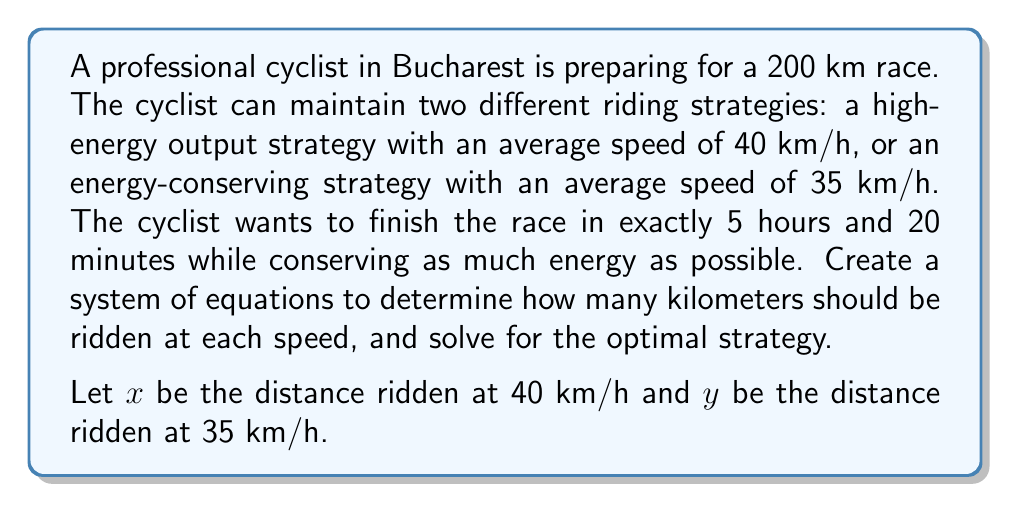Provide a solution to this math problem. To solve this problem, we need to set up a system of two equations based on the given information:

1. The total distance equation:
   $$x + y = 200$$
   This equation represents the fact that the sum of distances ridden at both speeds must equal the total race distance of 200 km.

2. The total time equation:
   $$\frac{x}{40} + \frac{y}{35} = \frac{16}{3}$$
   This equation represents the total time taken, which should be 5 hours and 20 minutes (or 16/3 hours).

Now we have a system of two equations with two unknowns:

$$\begin{cases}
x + y = 200 \\
\frac{x}{40} + \frac{y}{35} = \frac{16}{3}
\end{cases}$$

To solve this system:

1. Multiply the second equation by 140 (LCM of 40 and 35) to eliminate fractions:
   $$7x + 8y = 746\frac{2}{3}$$

2. Subtract the first equation from this new equation:
   $$6x + 7y = 546\frac{2}{3}$$

3. Subtract the first equation again:
   $$5x + 6y = 346\frac{2}{3}$$

4. Continue this process:
   $$4x + 5y = 146\frac{2}{3}$$
   $$3x + 4y = -53\frac{1}{3}$$
   $$2x + 3y = -253\frac{1}{3}$$
   $$x + 2y = -453\frac{1}{3}$$

5. Subtract $y$ times the first equation from the last equation:
   $$x = 146\frac{2}{3}$$

6. Substitute this value back into the first equation:
   $$y = 53\frac{1}{3}$$

Therefore, the cyclist should ride 146.67 km at 40 km/h and 53.33 km at 35 km/h to optimize the race strategy.
Answer: 146.67 km at 40 km/h, 53.33 km at 35 km/h 